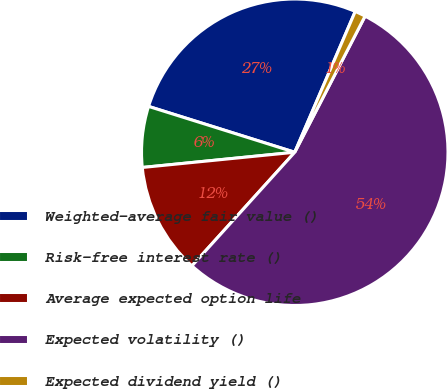<chart> <loc_0><loc_0><loc_500><loc_500><pie_chart><fcel>Weighted-average fair value ()<fcel>Risk-free interest rate ()<fcel>Average expected option life<fcel>Expected volatility ()<fcel>Expected dividend yield ()<nl><fcel>26.62%<fcel>6.42%<fcel>11.71%<fcel>54.11%<fcel>1.13%<nl></chart> 